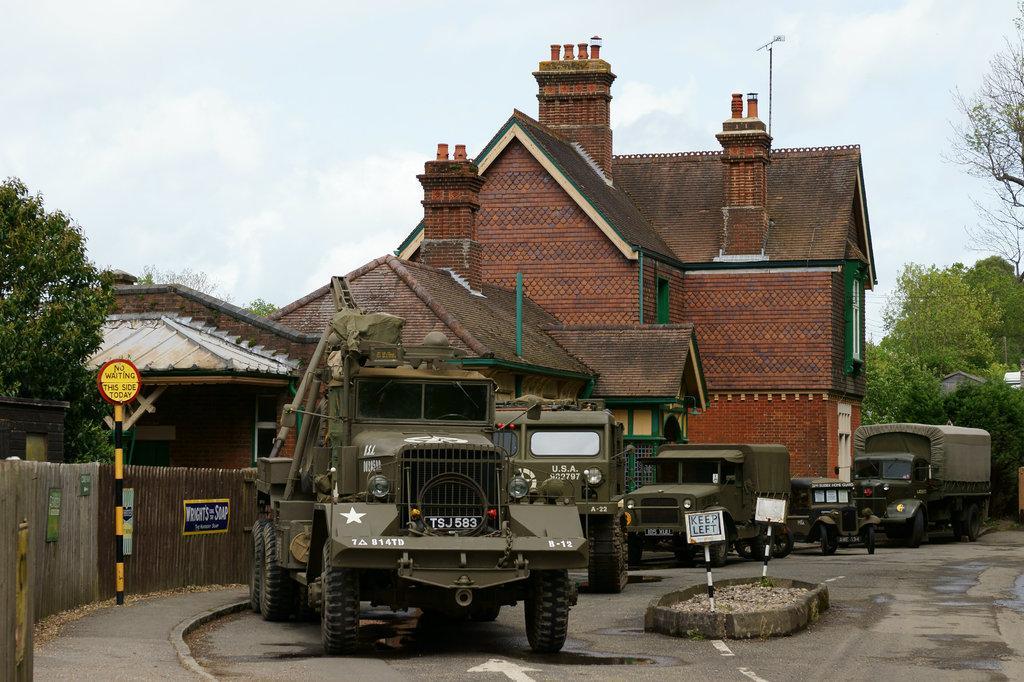In one or two sentences, can you explain what this image depicts? In this image, this looks like a building, with the windows. These are the vehicles on the road. On the left side of the image, I can see the posts attached to the wooden fence. I can see the boards to the poles. These are the trees. This is the sky. 